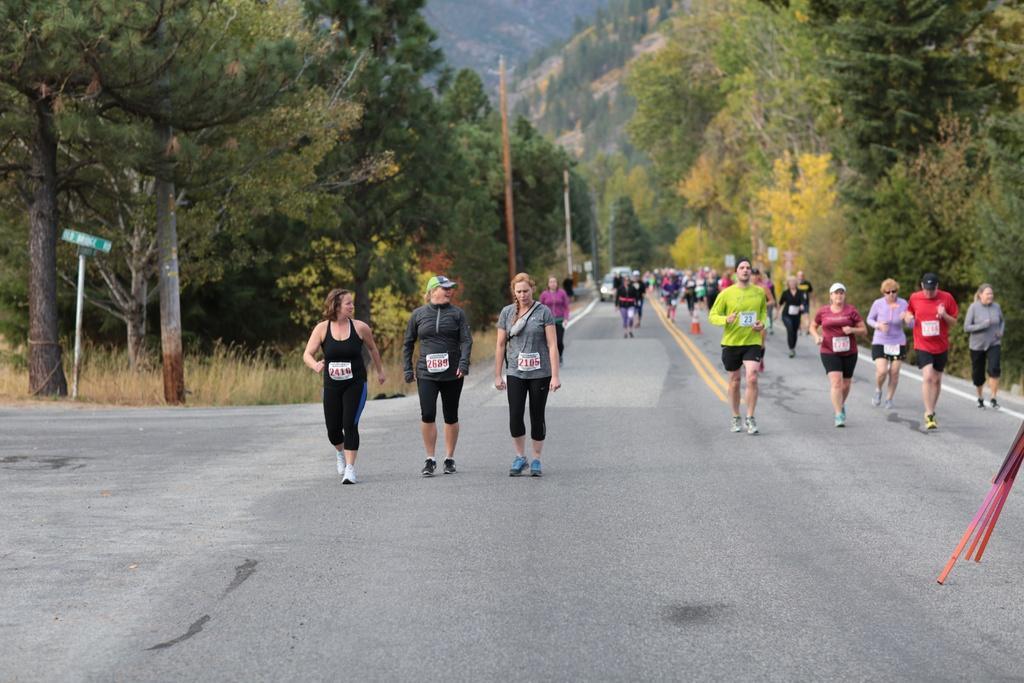In one or two sentences, can you explain what this image depicts? In the background we can see the thicket. In this picture we can see the trees, plants, poles, boards, traffic cone. We can see the people and objects. Far we can see a vehicle. 